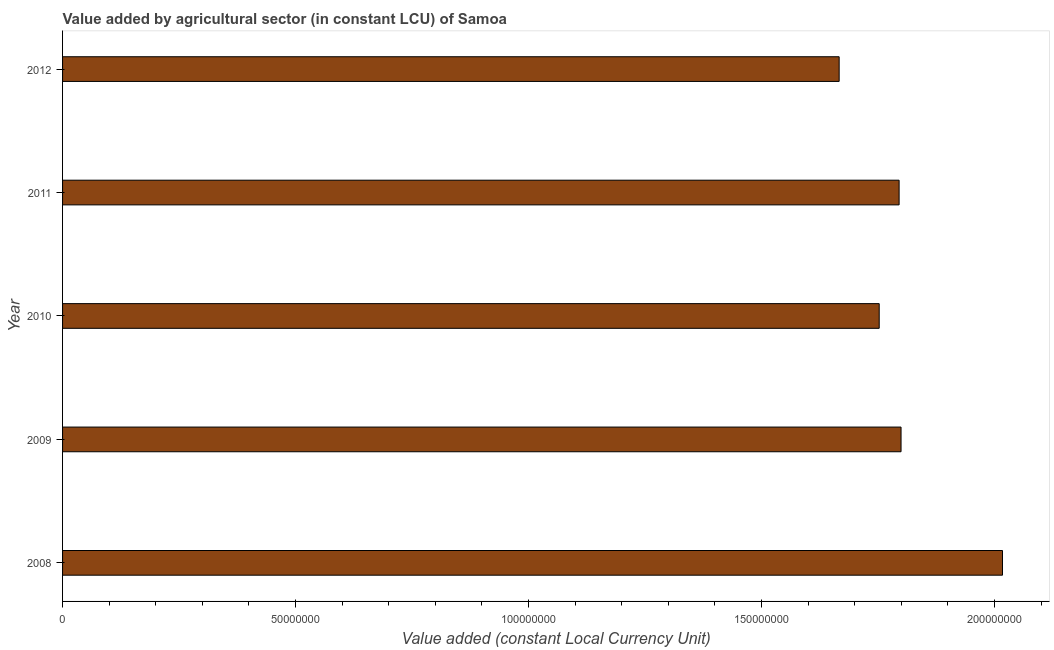What is the title of the graph?
Keep it short and to the point. Value added by agricultural sector (in constant LCU) of Samoa. What is the label or title of the X-axis?
Provide a succinct answer. Value added (constant Local Currency Unit). What is the label or title of the Y-axis?
Ensure brevity in your answer.  Year. What is the value added by agriculture sector in 2012?
Ensure brevity in your answer.  1.67e+08. Across all years, what is the maximum value added by agriculture sector?
Offer a terse response. 2.02e+08. Across all years, what is the minimum value added by agriculture sector?
Offer a terse response. 1.67e+08. In which year was the value added by agriculture sector minimum?
Make the answer very short. 2012. What is the sum of the value added by agriculture sector?
Your answer should be compact. 9.03e+08. What is the difference between the value added by agriculture sector in 2008 and 2010?
Keep it short and to the point. 2.65e+07. What is the average value added by agriculture sector per year?
Your answer should be compact. 1.81e+08. What is the median value added by agriculture sector?
Your answer should be compact. 1.80e+08. Do a majority of the years between 2008 and 2009 (inclusive) have value added by agriculture sector greater than 90000000 LCU?
Keep it short and to the point. Yes. What is the ratio of the value added by agriculture sector in 2009 to that in 2012?
Your answer should be very brief. 1.08. Is the value added by agriculture sector in 2008 less than that in 2009?
Offer a very short reply. No. What is the difference between the highest and the second highest value added by agriculture sector?
Offer a very short reply. 2.18e+07. What is the difference between the highest and the lowest value added by agriculture sector?
Your answer should be very brief. 3.51e+07. In how many years, is the value added by agriculture sector greater than the average value added by agriculture sector taken over all years?
Your answer should be compact. 1. How many bars are there?
Your response must be concise. 5. Are all the bars in the graph horizontal?
Your answer should be very brief. Yes. How many years are there in the graph?
Your answer should be very brief. 5. Are the values on the major ticks of X-axis written in scientific E-notation?
Your answer should be very brief. No. What is the Value added (constant Local Currency Unit) of 2008?
Keep it short and to the point. 2.02e+08. What is the Value added (constant Local Currency Unit) of 2009?
Provide a short and direct response. 1.80e+08. What is the Value added (constant Local Currency Unit) of 2010?
Keep it short and to the point. 1.75e+08. What is the Value added (constant Local Currency Unit) in 2011?
Offer a terse response. 1.80e+08. What is the Value added (constant Local Currency Unit) in 2012?
Give a very brief answer. 1.67e+08. What is the difference between the Value added (constant Local Currency Unit) in 2008 and 2009?
Offer a terse response. 2.18e+07. What is the difference between the Value added (constant Local Currency Unit) in 2008 and 2010?
Your answer should be compact. 2.65e+07. What is the difference between the Value added (constant Local Currency Unit) in 2008 and 2011?
Your answer should be very brief. 2.22e+07. What is the difference between the Value added (constant Local Currency Unit) in 2008 and 2012?
Your answer should be compact. 3.51e+07. What is the difference between the Value added (constant Local Currency Unit) in 2009 and 2010?
Your answer should be very brief. 4.69e+06. What is the difference between the Value added (constant Local Currency Unit) in 2009 and 2011?
Your response must be concise. 4.16e+05. What is the difference between the Value added (constant Local Currency Unit) in 2009 and 2012?
Make the answer very short. 1.33e+07. What is the difference between the Value added (constant Local Currency Unit) in 2010 and 2011?
Make the answer very short. -4.27e+06. What is the difference between the Value added (constant Local Currency Unit) in 2010 and 2012?
Keep it short and to the point. 8.60e+06. What is the difference between the Value added (constant Local Currency Unit) in 2011 and 2012?
Offer a terse response. 1.29e+07. What is the ratio of the Value added (constant Local Currency Unit) in 2008 to that in 2009?
Give a very brief answer. 1.12. What is the ratio of the Value added (constant Local Currency Unit) in 2008 to that in 2010?
Make the answer very short. 1.15. What is the ratio of the Value added (constant Local Currency Unit) in 2008 to that in 2011?
Provide a short and direct response. 1.12. What is the ratio of the Value added (constant Local Currency Unit) in 2008 to that in 2012?
Give a very brief answer. 1.21. What is the ratio of the Value added (constant Local Currency Unit) in 2010 to that in 2012?
Ensure brevity in your answer.  1.05. What is the ratio of the Value added (constant Local Currency Unit) in 2011 to that in 2012?
Your response must be concise. 1.08. 